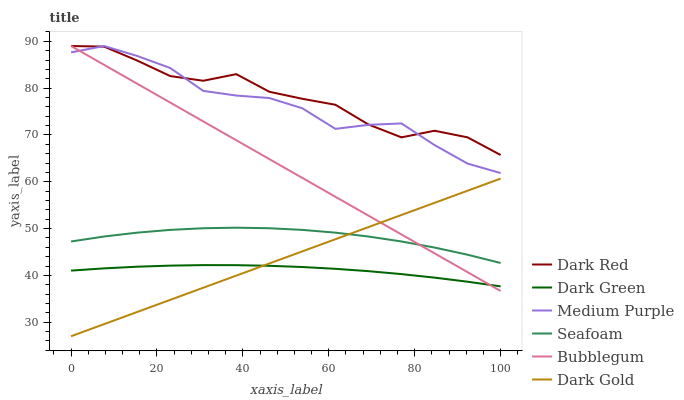Does Dark Green have the minimum area under the curve?
Answer yes or no. Yes. Does Dark Red have the maximum area under the curve?
Answer yes or no. Yes. Does Seafoam have the minimum area under the curve?
Answer yes or no. No. Does Seafoam have the maximum area under the curve?
Answer yes or no. No. Is Dark Gold the smoothest?
Answer yes or no. Yes. Is Dark Red the roughest?
Answer yes or no. Yes. Is Seafoam the smoothest?
Answer yes or no. No. Is Seafoam the roughest?
Answer yes or no. No. Does Dark Gold have the lowest value?
Answer yes or no. Yes. Does Seafoam have the lowest value?
Answer yes or no. No. Does Medium Purple have the highest value?
Answer yes or no. Yes. Does Seafoam have the highest value?
Answer yes or no. No. Is Dark Gold less than Dark Red?
Answer yes or no. Yes. Is Medium Purple greater than Seafoam?
Answer yes or no. Yes. Does Seafoam intersect Dark Gold?
Answer yes or no. Yes. Is Seafoam less than Dark Gold?
Answer yes or no. No. Is Seafoam greater than Dark Gold?
Answer yes or no. No. Does Dark Gold intersect Dark Red?
Answer yes or no. No. 